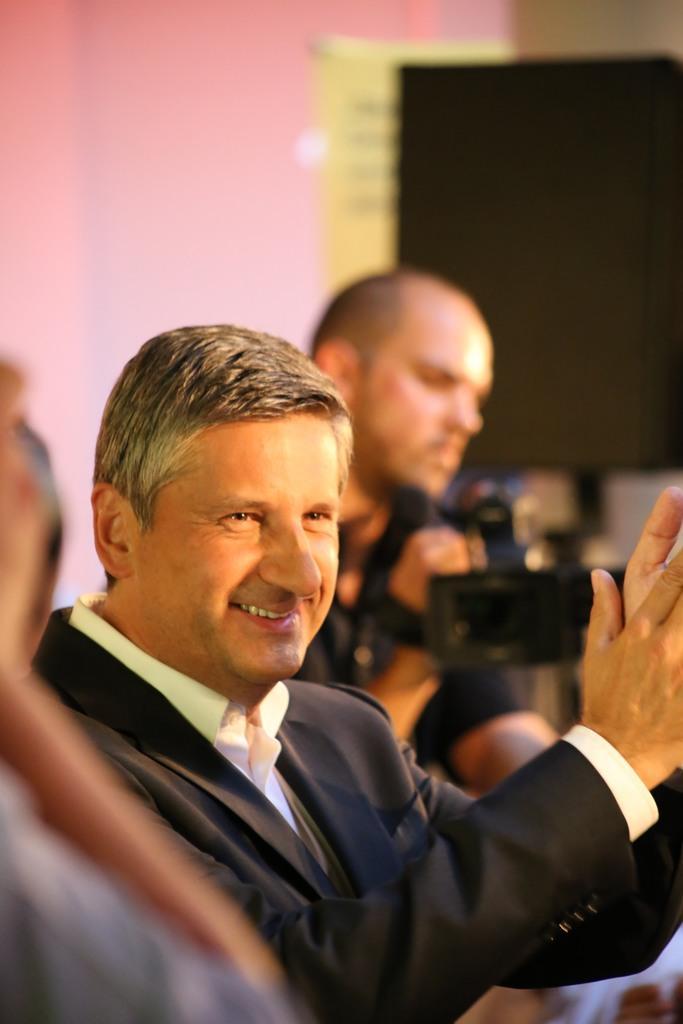In one or two sentences, can you explain what this image depicts? Here we can see people. This person is smiling and clapping his hands. Far another person is holding a camera. Background it is blur. We can see a wall and black board.  